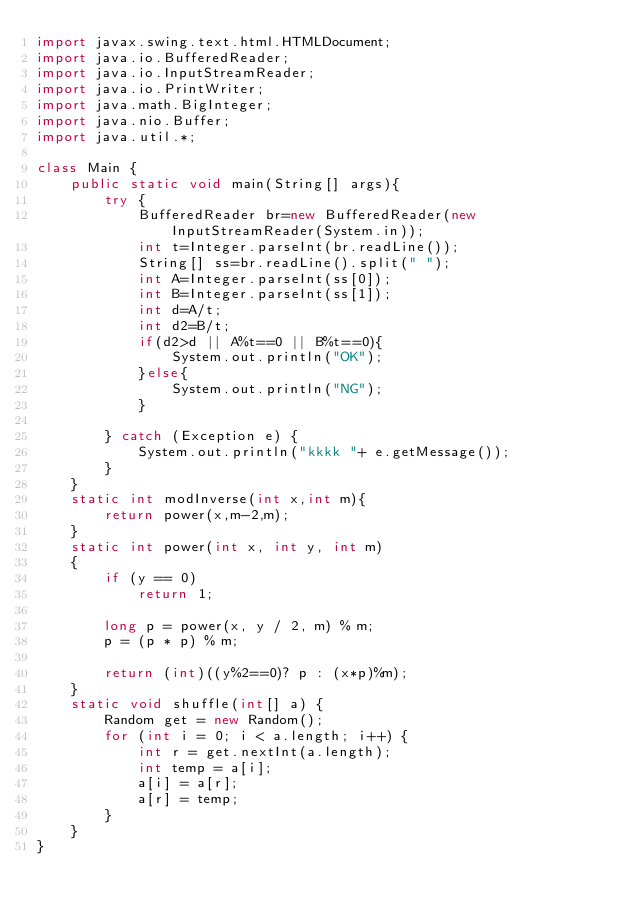<code> <loc_0><loc_0><loc_500><loc_500><_Java_>import javax.swing.text.html.HTMLDocument;
import java.io.BufferedReader;
import java.io.InputStreamReader;
import java.io.PrintWriter;
import java.math.BigInteger;
import java.nio.Buffer;
import java.util.*;

class Main {
    public static void main(String[] args){
        try {
            BufferedReader br=new BufferedReader(new InputStreamReader(System.in));
            int t=Integer.parseInt(br.readLine());
            String[] ss=br.readLine().split(" ");
            int A=Integer.parseInt(ss[0]);
            int B=Integer.parseInt(ss[1]);
            int d=A/t;
            int d2=B/t;
            if(d2>d || A%t==0 || B%t==0){
                System.out.println("OK");
            }else{
                System.out.println("NG");
            }

        } catch (Exception e) {
            System.out.println("kkkk "+ e.getMessage());
        }
    }
    static int modInverse(int x,int m){
        return power(x,m-2,m);
    }
    static int power(int x, int y, int m)
    {
        if (y == 0)
            return 1;

        long p = power(x, y / 2, m) % m;
        p = (p * p) % m;

        return (int)((y%2==0)? p : (x*p)%m);
    }
    static void shuffle(int[] a) {
        Random get = new Random();
        for (int i = 0; i < a.length; i++) {
            int r = get.nextInt(a.length);
            int temp = a[i];
            a[i] = a[r];
            a[r] = temp;
        }
    }
}</code> 